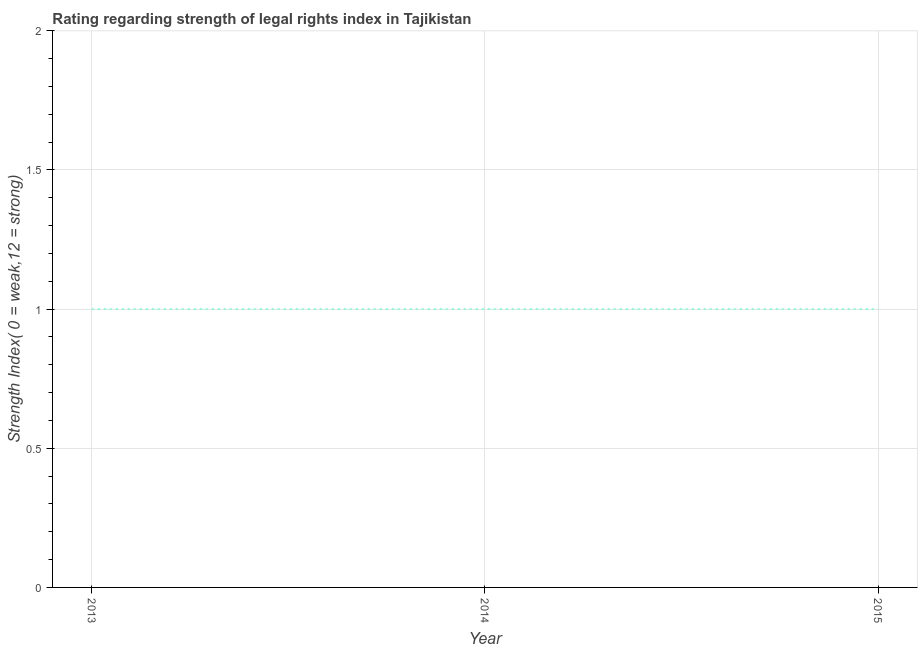What is the strength of legal rights index in 2015?
Your answer should be compact. 1. Across all years, what is the maximum strength of legal rights index?
Your answer should be compact. 1. Across all years, what is the minimum strength of legal rights index?
Your answer should be very brief. 1. In which year was the strength of legal rights index maximum?
Your response must be concise. 2013. In which year was the strength of legal rights index minimum?
Provide a short and direct response. 2013. What is the sum of the strength of legal rights index?
Give a very brief answer. 3. What is the difference between the strength of legal rights index in 2013 and 2015?
Give a very brief answer. 0. What is the average strength of legal rights index per year?
Give a very brief answer. 1. What is the median strength of legal rights index?
Your answer should be very brief. 1. Do a majority of the years between 2013 and 2014 (inclusive) have strength of legal rights index greater than 1.1 ?
Provide a succinct answer. No. What is the ratio of the strength of legal rights index in 2013 to that in 2014?
Your response must be concise. 1. Is the difference between the strength of legal rights index in 2013 and 2015 greater than the difference between any two years?
Give a very brief answer. Yes. What is the difference between the highest and the second highest strength of legal rights index?
Your answer should be very brief. 0. Is the sum of the strength of legal rights index in 2014 and 2015 greater than the maximum strength of legal rights index across all years?
Keep it short and to the point. Yes. What is the difference between the highest and the lowest strength of legal rights index?
Ensure brevity in your answer.  0. How many years are there in the graph?
Ensure brevity in your answer.  3. Are the values on the major ticks of Y-axis written in scientific E-notation?
Offer a very short reply. No. Does the graph contain grids?
Provide a short and direct response. Yes. What is the title of the graph?
Your answer should be very brief. Rating regarding strength of legal rights index in Tajikistan. What is the label or title of the X-axis?
Offer a terse response. Year. What is the label or title of the Y-axis?
Make the answer very short. Strength Index( 0 = weak,12 = strong). What is the Strength Index( 0 = weak,12 = strong) of 2013?
Make the answer very short. 1. What is the Strength Index( 0 = weak,12 = strong) of 2014?
Your answer should be compact. 1. What is the Strength Index( 0 = weak,12 = strong) in 2015?
Keep it short and to the point. 1. What is the difference between the Strength Index( 0 = weak,12 = strong) in 2013 and 2015?
Your answer should be very brief. 0. What is the difference between the Strength Index( 0 = weak,12 = strong) in 2014 and 2015?
Keep it short and to the point. 0. 